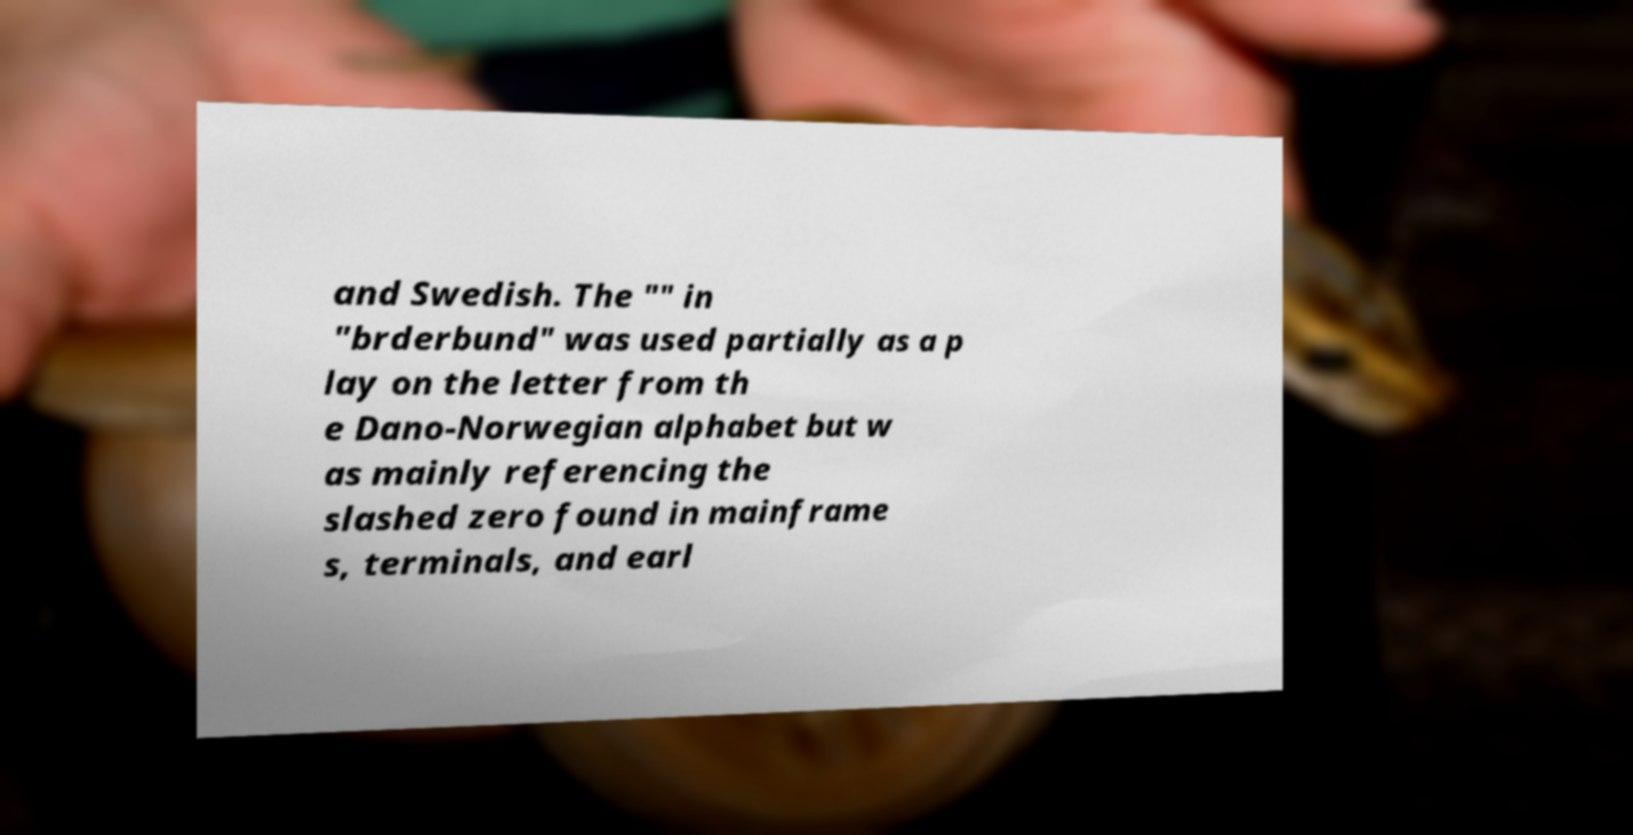Please identify and transcribe the text found in this image. and Swedish. The "" in "brderbund" was used partially as a p lay on the letter from th e Dano-Norwegian alphabet but w as mainly referencing the slashed zero found in mainframe s, terminals, and earl 